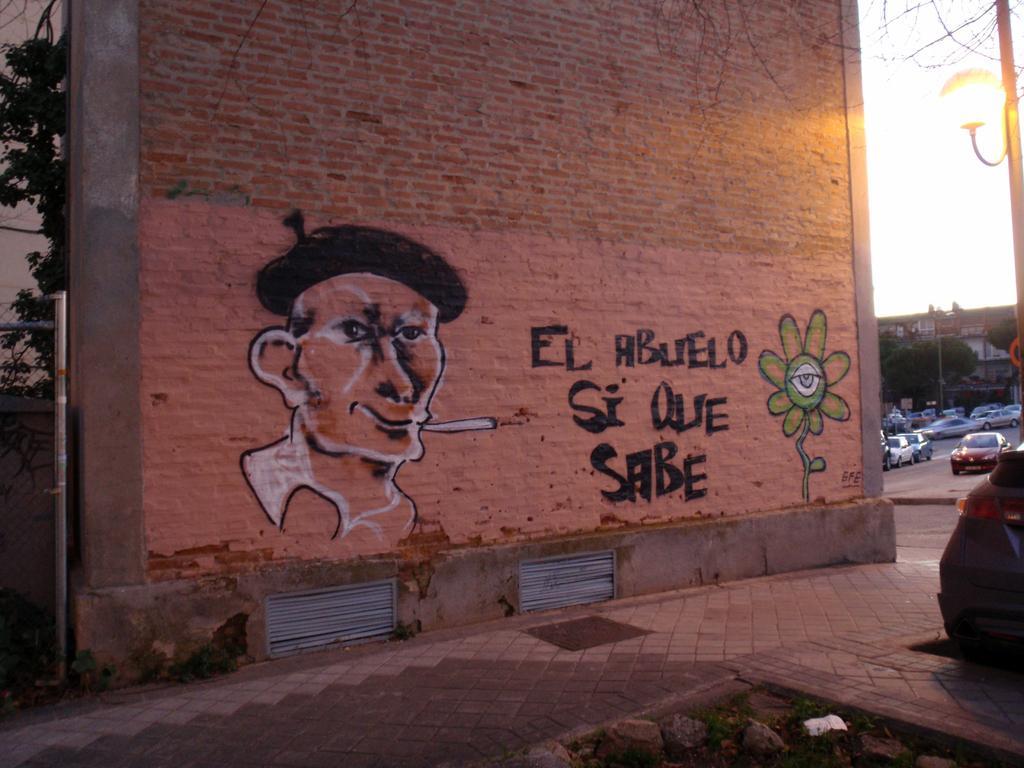Can you describe this image briefly? In this image there is a picture and a text on the wall, beside the wall there are cars in the parking lot, beside the cars there are trees and buildings and there is a lamp post. 